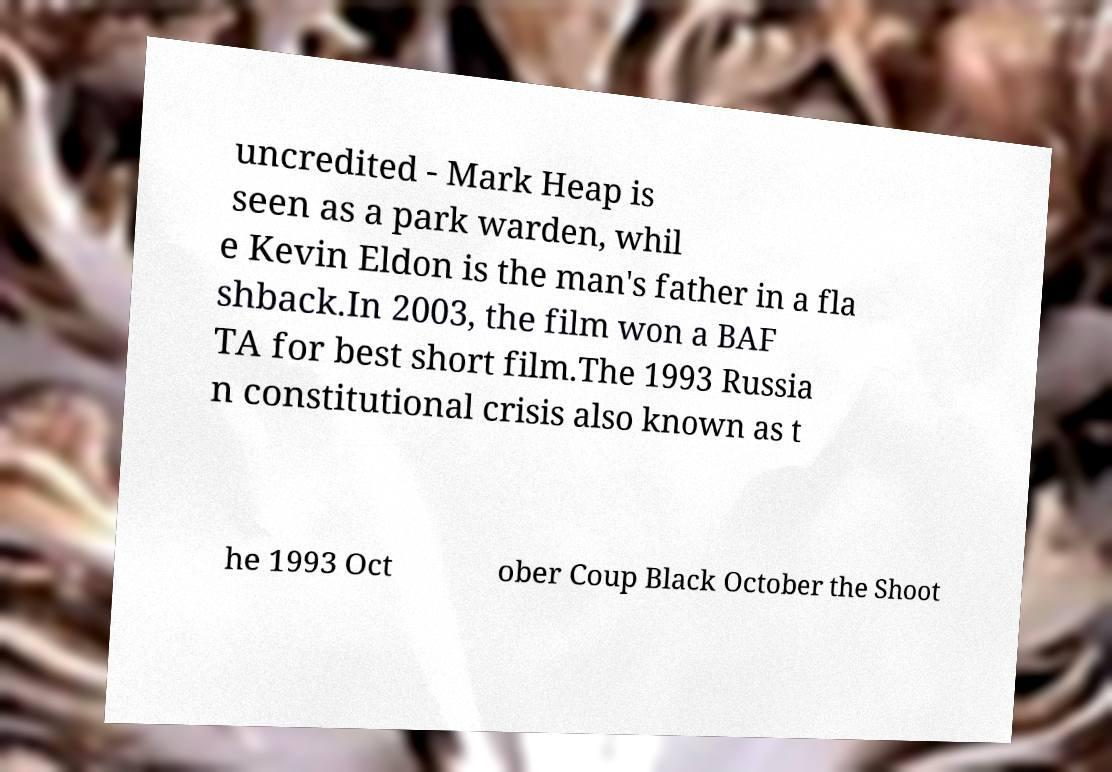Please identify and transcribe the text found in this image. uncredited - Mark Heap is seen as a park warden, whil e Kevin Eldon is the man's father in a fla shback.In 2003, the film won a BAF TA for best short film.The 1993 Russia n constitutional crisis also known as t he 1993 Oct ober Coup Black October the Shoot 